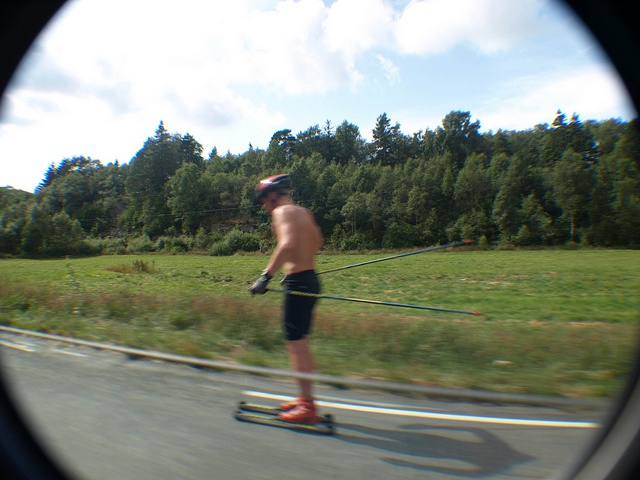Describe the objects in this image and their specific colors. I can see people in black, brown, and gray tones and skis in black, gray, maroon, olive, and teal tones in this image. 